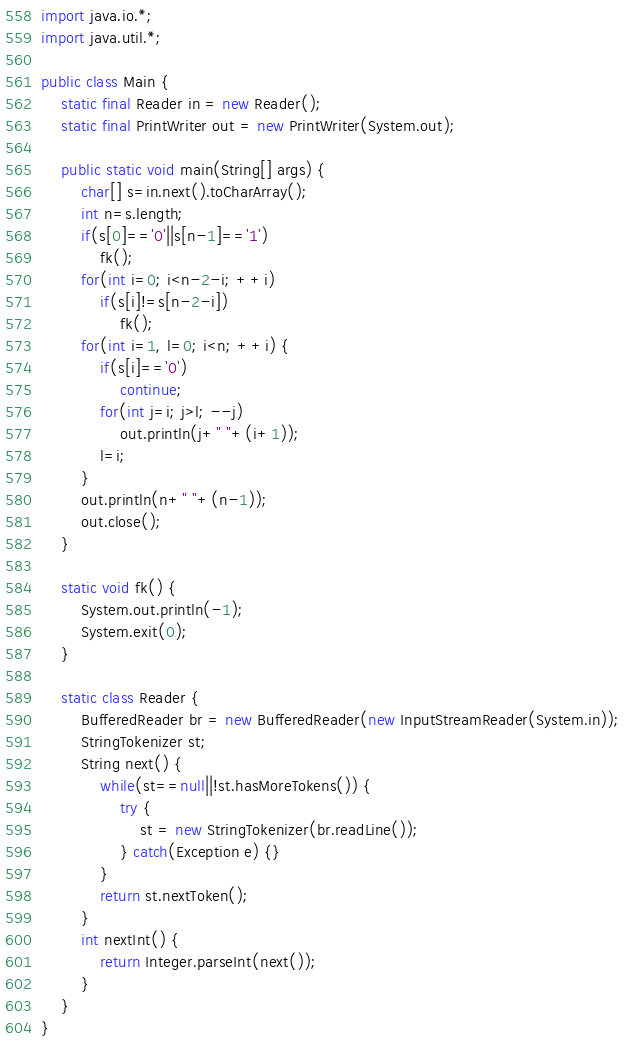Convert code to text. <code><loc_0><loc_0><loc_500><loc_500><_Java_>import java.io.*;
import java.util.*;

public class Main {
	static final Reader in = new Reader();
	static final PrintWriter out = new PrintWriter(System.out);
	
	public static void main(String[] args) {
		char[] s=in.next().toCharArray();
		int n=s.length;
		if(s[0]=='0'||s[n-1]=='1')
			fk();
		for(int i=0; i<n-2-i; ++i)
			if(s[i]!=s[n-2-i])
				fk();
		for(int i=1, l=0; i<n; ++i) {
			if(s[i]=='0')
				continue;
			for(int j=i; j>l; --j)
				out.println(j+" "+(i+1));
			l=i;
		}
		out.println(n+" "+(n-1));
		out.close();
	}
	
	static void fk() {
		System.out.println(-1);
		System.exit(0);
	}
	
	static class Reader {
		BufferedReader br = new BufferedReader(new InputStreamReader(System.in));
		StringTokenizer st;
		String next() {
			while(st==null||!st.hasMoreTokens()) {
				try {
					st = new StringTokenizer(br.readLine());
				} catch(Exception e) {}
			}
			return st.nextToken();
		}
		int nextInt() {
			return Integer.parseInt(next());
		}
	}
}</code> 